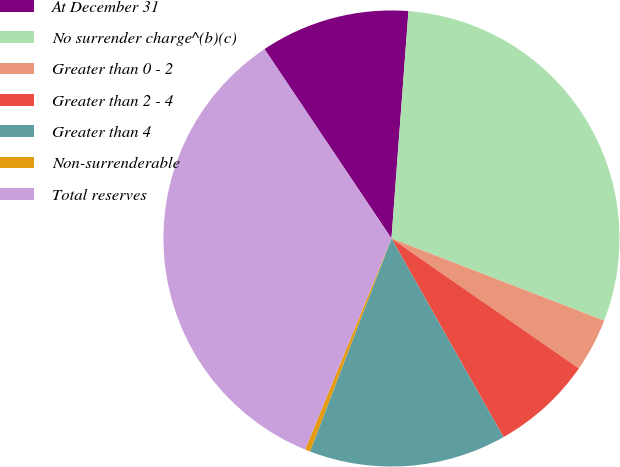Convert chart. <chart><loc_0><loc_0><loc_500><loc_500><pie_chart><fcel>At December 31<fcel>No surrender charge^(b)(c)<fcel>Greater than 0 - 2<fcel>Greater than 2 - 4<fcel>Greater than 4<fcel>Non-surrenderable<fcel>Total reserves<nl><fcel>10.59%<fcel>29.68%<fcel>3.78%<fcel>7.18%<fcel>13.99%<fcel>0.37%<fcel>34.42%<nl></chart> 